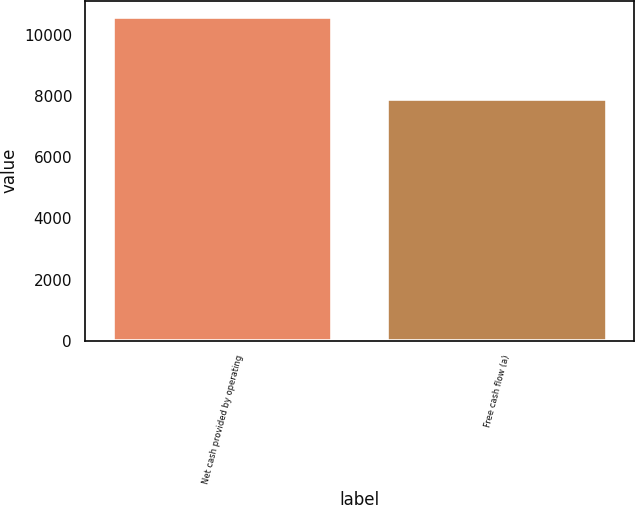<chart> <loc_0><loc_0><loc_500><loc_500><bar_chart><fcel>Net cash provided by operating<fcel>Free cash flow (a)<nl><fcel>10580<fcel>7908<nl></chart> 